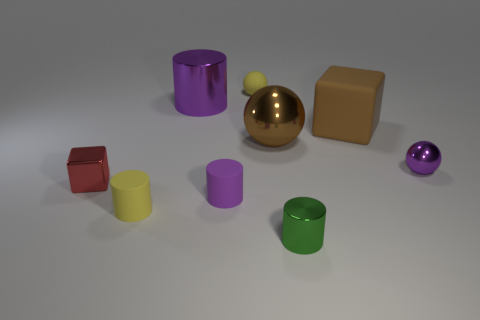How many tiny objects are either red things or cyan rubber blocks?
Keep it short and to the point. 1. What is the shape of the large brown matte object?
Provide a short and direct response. Cube. There is a rubber thing that is the same color as the matte sphere; what size is it?
Offer a terse response. Small. Is there a big cube made of the same material as the small green cylinder?
Your response must be concise. No. Are there more small metal balls than yellow things?
Provide a succinct answer. No. Is the material of the large brown ball the same as the small red cube?
Provide a short and direct response. Yes. What number of rubber objects are either large cylinders or cyan balls?
Keep it short and to the point. 0. There is a rubber ball that is the same size as the purple matte object; what color is it?
Your response must be concise. Yellow. What number of small green things are the same shape as the purple matte object?
Offer a terse response. 1. How many cylinders are either tiny yellow objects or large brown things?
Make the answer very short. 1. 